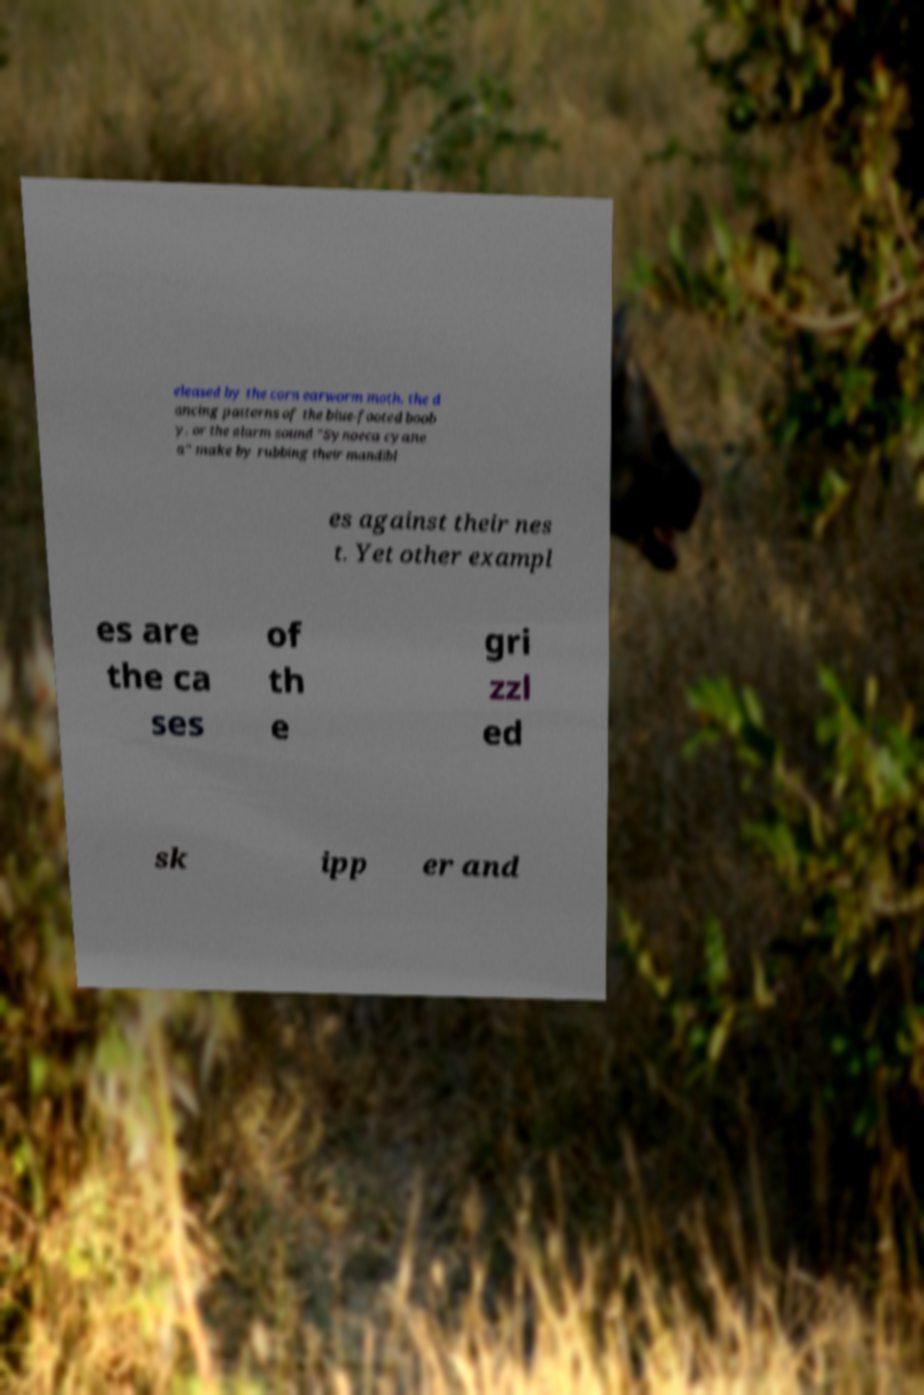Could you assist in decoding the text presented in this image and type it out clearly? eleased by the corn earworm moth, the d ancing patterns of the blue-footed boob y, or the alarm sound "Synoeca cyane a" make by rubbing their mandibl es against their nes t. Yet other exampl es are the ca ses of th e gri zzl ed sk ipp er and 